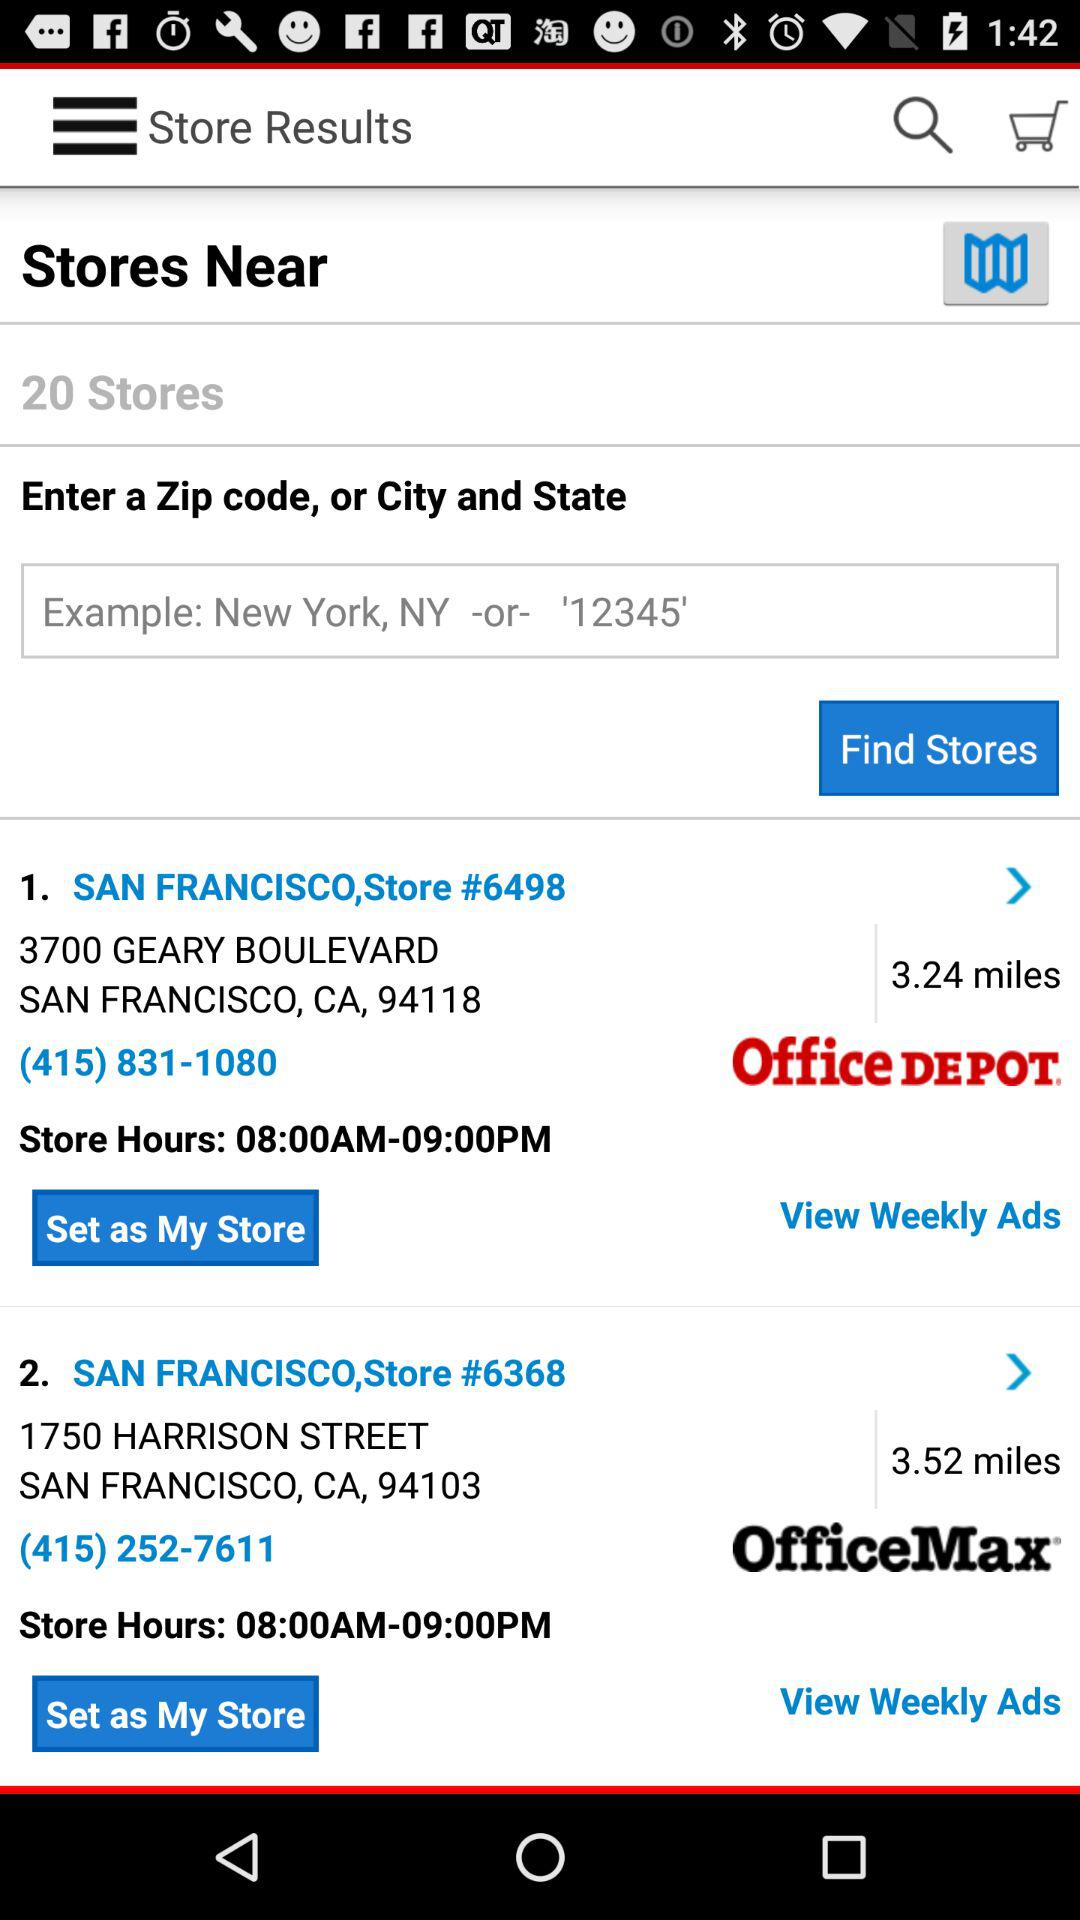What is the address of San Francisco, store #6498? The address is 3700 Geary Boulevard, San Francisco, CA, 94118. 